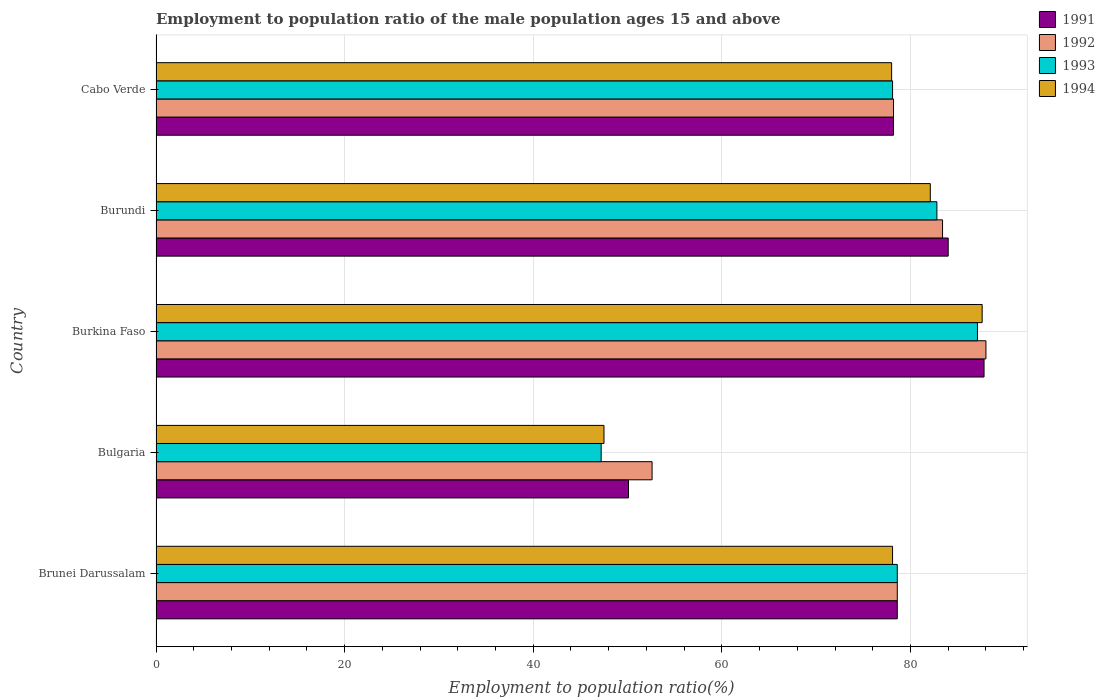What is the label of the 5th group of bars from the top?
Give a very brief answer. Brunei Darussalam. In how many cases, is the number of bars for a given country not equal to the number of legend labels?
Your answer should be compact. 0. What is the employment to population ratio in 1992 in Brunei Darussalam?
Provide a succinct answer. 78.6. Across all countries, what is the maximum employment to population ratio in 1993?
Ensure brevity in your answer.  87.1. Across all countries, what is the minimum employment to population ratio in 1994?
Your response must be concise. 47.5. In which country was the employment to population ratio in 1991 maximum?
Your answer should be very brief. Burkina Faso. What is the total employment to population ratio in 1994 in the graph?
Your answer should be compact. 373.3. What is the difference between the employment to population ratio in 1993 in Burundi and that in Cabo Verde?
Offer a very short reply. 4.7. What is the difference between the employment to population ratio in 1994 in Cabo Verde and the employment to population ratio in 1992 in Burkina Faso?
Provide a succinct answer. -10. What is the average employment to population ratio in 1993 per country?
Keep it short and to the point. 74.76. What is the difference between the employment to population ratio in 1991 and employment to population ratio in 1993 in Burkina Faso?
Keep it short and to the point. 0.7. What is the ratio of the employment to population ratio in 1991 in Bulgaria to that in Cabo Verde?
Your answer should be compact. 0.64. Is the employment to population ratio in 1991 in Burkina Faso less than that in Cabo Verde?
Provide a succinct answer. No. What is the difference between the highest and the second highest employment to population ratio in 1992?
Make the answer very short. 4.6. What is the difference between the highest and the lowest employment to population ratio in 1994?
Your answer should be very brief. 40.1. What does the 1st bar from the top in Brunei Darussalam represents?
Keep it short and to the point. 1994. Is it the case that in every country, the sum of the employment to population ratio in 1992 and employment to population ratio in 1994 is greater than the employment to population ratio in 1993?
Offer a very short reply. Yes. How many bars are there?
Your answer should be very brief. 20. Are all the bars in the graph horizontal?
Your answer should be compact. Yes. Are the values on the major ticks of X-axis written in scientific E-notation?
Give a very brief answer. No. Does the graph contain any zero values?
Your response must be concise. No. Does the graph contain grids?
Provide a succinct answer. Yes. Where does the legend appear in the graph?
Give a very brief answer. Top right. How many legend labels are there?
Offer a very short reply. 4. How are the legend labels stacked?
Provide a short and direct response. Vertical. What is the title of the graph?
Your answer should be compact. Employment to population ratio of the male population ages 15 and above. What is the label or title of the X-axis?
Your answer should be compact. Employment to population ratio(%). What is the label or title of the Y-axis?
Your answer should be compact. Country. What is the Employment to population ratio(%) in 1991 in Brunei Darussalam?
Ensure brevity in your answer.  78.6. What is the Employment to population ratio(%) of 1992 in Brunei Darussalam?
Offer a terse response. 78.6. What is the Employment to population ratio(%) in 1993 in Brunei Darussalam?
Make the answer very short. 78.6. What is the Employment to population ratio(%) in 1994 in Brunei Darussalam?
Offer a very short reply. 78.1. What is the Employment to population ratio(%) in 1991 in Bulgaria?
Offer a terse response. 50.1. What is the Employment to population ratio(%) in 1992 in Bulgaria?
Your answer should be compact. 52.6. What is the Employment to population ratio(%) of 1993 in Bulgaria?
Offer a very short reply. 47.2. What is the Employment to population ratio(%) in 1994 in Bulgaria?
Keep it short and to the point. 47.5. What is the Employment to population ratio(%) of 1991 in Burkina Faso?
Provide a short and direct response. 87.8. What is the Employment to population ratio(%) of 1992 in Burkina Faso?
Make the answer very short. 88. What is the Employment to population ratio(%) of 1993 in Burkina Faso?
Your response must be concise. 87.1. What is the Employment to population ratio(%) of 1994 in Burkina Faso?
Your answer should be compact. 87.6. What is the Employment to population ratio(%) in 1991 in Burundi?
Offer a terse response. 84. What is the Employment to population ratio(%) in 1992 in Burundi?
Provide a short and direct response. 83.4. What is the Employment to population ratio(%) of 1993 in Burundi?
Give a very brief answer. 82.8. What is the Employment to population ratio(%) in 1994 in Burundi?
Provide a short and direct response. 82.1. What is the Employment to population ratio(%) of 1991 in Cabo Verde?
Give a very brief answer. 78.2. What is the Employment to population ratio(%) in 1992 in Cabo Verde?
Offer a terse response. 78.2. What is the Employment to population ratio(%) of 1993 in Cabo Verde?
Your response must be concise. 78.1. Across all countries, what is the maximum Employment to population ratio(%) of 1991?
Offer a very short reply. 87.8. Across all countries, what is the maximum Employment to population ratio(%) of 1993?
Provide a short and direct response. 87.1. Across all countries, what is the maximum Employment to population ratio(%) of 1994?
Offer a very short reply. 87.6. Across all countries, what is the minimum Employment to population ratio(%) in 1991?
Offer a terse response. 50.1. Across all countries, what is the minimum Employment to population ratio(%) in 1992?
Give a very brief answer. 52.6. Across all countries, what is the minimum Employment to population ratio(%) of 1993?
Provide a succinct answer. 47.2. Across all countries, what is the minimum Employment to population ratio(%) in 1994?
Give a very brief answer. 47.5. What is the total Employment to population ratio(%) in 1991 in the graph?
Your answer should be compact. 378.7. What is the total Employment to population ratio(%) of 1992 in the graph?
Ensure brevity in your answer.  380.8. What is the total Employment to population ratio(%) in 1993 in the graph?
Offer a terse response. 373.8. What is the total Employment to population ratio(%) in 1994 in the graph?
Your response must be concise. 373.3. What is the difference between the Employment to population ratio(%) in 1991 in Brunei Darussalam and that in Bulgaria?
Give a very brief answer. 28.5. What is the difference between the Employment to population ratio(%) of 1992 in Brunei Darussalam and that in Bulgaria?
Give a very brief answer. 26. What is the difference between the Employment to population ratio(%) in 1993 in Brunei Darussalam and that in Bulgaria?
Offer a terse response. 31.4. What is the difference between the Employment to population ratio(%) of 1994 in Brunei Darussalam and that in Bulgaria?
Your answer should be very brief. 30.6. What is the difference between the Employment to population ratio(%) in 1991 in Brunei Darussalam and that in Burkina Faso?
Offer a terse response. -9.2. What is the difference between the Employment to population ratio(%) in 1993 in Brunei Darussalam and that in Burkina Faso?
Provide a short and direct response. -8.5. What is the difference between the Employment to population ratio(%) of 1992 in Brunei Darussalam and that in Burundi?
Your answer should be compact. -4.8. What is the difference between the Employment to population ratio(%) in 1993 in Brunei Darussalam and that in Burundi?
Offer a very short reply. -4.2. What is the difference between the Employment to population ratio(%) in 1992 in Brunei Darussalam and that in Cabo Verde?
Offer a very short reply. 0.4. What is the difference between the Employment to population ratio(%) in 1991 in Bulgaria and that in Burkina Faso?
Your answer should be very brief. -37.7. What is the difference between the Employment to population ratio(%) of 1992 in Bulgaria and that in Burkina Faso?
Give a very brief answer. -35.4. What is the difference between the Employment to population ratio(%) of 1993 in Bulgaria and that in Burkina Faso?
Offer a very short reply. -39.9. What is the difference between the Employment to population ratio(%) of 1994 in Bulgaria and that in Burkina Faso?
Keep it short and to the point. -40.1. What is the difference between the Employment to population ratio(%) of 1991 in Bulgaria and that in Burundi?
Offer a terse response. -33.9. What is the difference between the Employment to population ratio(%) in 1992 in Bulgaria and that in Burundi?
Make the answer very short. -30.8. What is the difference between the Employment to population ratio(%) in 1993 in Bulgaria and that in Burundi?
Give a very brief answer. -35.6. What is the difference between the Employment to population ratio(%) of 1994 in Bulgaria and that in Burundi?
Make the answer very short. -34.6. What is the difference between the Employment to population ratio(%) in 1991 in Bulgaria and that in Cabo Verde?
Ensure brevity in your answer.  -28.1. What is the difference between the Employment to population ratio(%) of 1992 in Bulgaria and that in Cabo Verde?
Give a very brief answer. -25.6. What is the difference between the Employment to population ratio(%) in 1993 in Bulgaria and that in Cabo Verde?
Your answer should be very brief. -30.9. What is the difference between the Employment to population ratio(%) in 1994 in Bulgaria and that in Cabo Verde?
Keep it short and to the point. -30.5. What is the difference between the Employment to population ratio(%) of 1992 in Burkina Faso and that in Burundi?
Your response must be concise. 4.6. What is the difference between the Employment to population ratio(%) of 1994 in Burkina Faso and that in Burundi?
Ensure brevity in your answer.  5.5. What is the difference between the Employment to population ratio(%) of 1993 in Burundi and that in Cabo Verde?
Your response must be concise. 4.7. What is the difference between the Employment to population ratio(%) of 1991 in Brunei Darussalam and the Employment to population ratio(%) of 1993 in Bulgaria?
Make the answer very short. 31.4. What is the difference between the Employment to population ratio(%) in 1991 in Brunei Darussalam and the Employment to population ratio(%) in 1994 in Bulgaria?
Keep it short and to the point. 31.1. What is the difference between the Employment to population ratio(%) of 1992 in Brunei Darussalam and the Employment to population ratio(%) of 1993 in Bulgaria?
Your answer should be compact. 31.4. What is the difference between the Employment to population ratio(%) in 1992 in Brunei Darussalam and the Employment to population ratio(%) in 1994 in Bulgaria?
Offer a very short reply. 31.1. What is the difference between the Employment to population ratio(%) of 1993 in Brunei Darussalam and the Employment to population ratio(%) of 1994 in Bulgaria?
Offer a very short reply. 31.1. What is the difference between the Employment to population ratio(%) of 1991 in Brunei Darussalam and the Employment to population ratio(%) of 1994 in Burkina Faso?
Your response must be concise. -9. What is the difference between the Employment to population ratio(%) of 1992 in Brunei Darussalam and the Employment to population ratio(%) of 1993 in Burkina Faso?
Provide a succinct answer. -8.5. What is the difference between the Employment to population ratio(%) in 1991 in Brunei Darussalam and the Employment to population ratio(%) in 1993 in Burundi?
Offer a very short reply. -4.2. What is the difference between the Employment to population ratio(%) in 1991 in Brunei Darussalam and the Employment to population ratio(%) in 1994 in Burundi?
Make the answer very short. -3.5. What is the difference between the Employment to population ratio(%) in 1992 in Brunei Darussalam and the Employment to population ratio(%) in 1994 in Burundi?
Your answer should be very brief. -3.5. What is the difference between the Employment to population ratio(%) of 1993 in Brunei Darussalam and the Employment to population ratio(%) of 1994 in Burundi?
Ensure brevity in your answer.  -3.5. What is the difference between the Employment to population ratio(%) of 1991 in Brunei Darussalam and the Employment to population ratio(%) of 1993 in Cabo Verde?
Give a very brief answer. 0.5. What is the difference between the Employment to population ratio(%) of 1992 in Brunei Darussalam and the Employment to population ratio(%) of 1993 in Cabo Verde?
Give a very brief answer. 0.5. What is the difference between the Employment to population ratio(%) of 1992 in Brunei Darussalam and the Employment to population ratio(%) of 1994 in Cabo Verde?
Give a very brief answer. 0.6. What is the difference between the Employment to population ratio(%) of 1993 in Brunei Darussalam and the Employment to population ratio(%) of 1994 in Cabo Verde?
Your answer should be very brief. 0.6. What is the difference between the Employment to population ratio(%) in 1991 in Bulgaria and the Employment to population ratio(%) in 1992 in Burkina Faso?
Your answer should be very brief. -37.9. What is the difference between the Employment to population ratio(%) in 1991 in Bulgaria and the Employment to population ratio(%) in 1993 in Burkina Faso?
Offer a very short reply. -37. What is the difference between the Employment to population ratio(%) of 1991 in Bulgaria and the Employment to population ratio(%) of 1994 in Burkina Faso?
Your answer should be very brief. -37.5. What is the difference between the Employment to population ratio(%) in 1992 in Bulgaria and the Employment to population ratio(%) in 1993 in Burkina Faso?
Ensure brevity in your answer.  -34.5. What is the difference between the Employment to population ratio(%) in 1992 in Bulgaria and the Employment to population ratio(%) in 1994 in Burkina Faso?
Your answer should be compact. -35. What is the difference between the Employment to population ratio(%) of 1993 in Bulgaria and the Employment to population ratio(%) of 1994 in Burkina Faso?
Offer a terse response. -40.4. What is the difference between the Employment to population ratio(%) in 1991 in Bulgaria and the Employment to population ratio(%) in 1992 in Burundi?
Give a very brief answer. -33.3. What is the difference between the Employment to population ratio(%) of 1991 in Bulgaria and the Employment to population ratio(%) of 1993 in Burundi?
Give a very brief answer. -32.7. What is the difference between the Employment to population ratio(%) of 1991 in Bulgaria and the Employment to population ratio(%) of 1994 in Burundi?
Your answer should be very brief. -32. What is the difference between the Employment to population ratio(%) in 1992 in Bulgaria and the Employment to population ratio(%) in 1993 in Burundi?
Give a very brief answer. -30.2. What is the difference between the Employment to population ratio(%) of 1992 in Bulgaria and the Employment to population ratio(%) of 1994 in Burundi?
Keep it short and to the point. -29.5. What is the difference between the Employment to population ratio(%) in 1993 in Bulgaria and the Employment to population ratio(%) in 1994 in Burundi?
Offer a terse response. -34.9. What is the difference between the Employment to population ratio(%) of 1991 in Bulgaria and the Employment to population ratio(%) of 1992 in Cabo Verde?
Provide a short and direct response. -28.1. What is the difference between the Employment to population ratio(%) of 1991 in Bulgaria and the Employment to population ratio(%) of 1993 in Cabo Verde?
Offer a very short reply. -28. What is the difference between the Employment to population ratio(%) in 1991 in Bulgaria and the Employment to population ratio(%) in 1994 in Cabo Verde?
Offer a terse response. -27.9. What is the difference between the Employment to population ratio(%) in 1992 in Bulgaria and the Employment to population ratio(%) in 1993 in Cabo Verde?
Give a very brief answer. -25.5. What is the difference between the Employment to population ratio(%) of 1992 in Bulgaria and the Employment to population ratio(%) of 1994 in Cabo Verde?
Give a very brief answer. -25.4. What is the difference between the Employment to population ratio(%) of 1993 in Bulgaria and the Employment to population ratio(%) of 1994 in Cabo Verde?
Offer a very short reply. -30.8. What is the difference between the Employment to population ratio(%) of 1993 in Burkina Faso and the Employment to population ratio(%) of 1994 in Burundi?
Make the answer very short. 5. What is the difference between the Employment to population ratio(%) in 1991 in Burkina Faso and the Employment to population ratio(%) in 1992 in Cabo Verde?
Provide a short and direct response. 9.6. What is the difference between the Employment to population ratio(%) in 1991 in Burkina Faso and the Employment to population ratio(%) in 1993 in Cabo Verde?
Your answer should be compact. 9.7. What is the difference between the Employment to population ratio(%) of 1991 in Burkina Faso and the Employment to population ratio(%) of 1994 in Cabo Verde?
Your answer should be compact. 9.8. What is the difference between the Employment to population ratio(%) in 1992 in Burkina Faso and the Employment to population ratio(%) in 1994 in Cabo Verde?
Your answer should be compact. 10. What is the difference between the Employment to population ratio(%) in 1991 in Burundi and the Employment to population ratio(%) in 1993 in Cabo Verde?
Ensure brevity in your answer.  5.9. What is the difference between the Employment to population ratio(%) of 1992 in Burundi and the Employment to population ratio(%) of 1994 in Cabo Verde?
Give a very brief answer. 5.4. What is the average Employment to population ratio(%) of 1991 per country?
Provide a short and direct response. 75.74. What is the average Employment to population ratio(%) in 1992 per country?
Provide a succinct answer. 76.16. What is the average Employment to population ratio(%) of 1993 per country?
Offer a terse response. 74.76. What is the average Employment to population ratio(%) in 1994 per country?
Ensure brevity in your answer.  74.66. What is the difference between the Employment to population ratio(%) in 1991 and Employment to population ratio(%) in 1992 in Brunei Darussalam?
Your answer should be very brief. 0. What is the difference between the Employment to population ratio(%) of 1991 and Employment to population ratio(%) of 1993 in Brunei Darussalam?
Ensure brevity in your answer.  0. What is the difference between the Employment to population ratio(%) in 1992 and Employment to population ratio(%) in 1993 in Brunei Darussalam?
Make the answer very short. 0. What is the difference between the Employment to population ratio(%) of 1992 and Employment to population ratio(%) of 1994 in Brunei Darussalam?
Provide a short and direct response. 0.5. What is the difference between the Employment to population ratio(%) of 1993 and Employment to population ratio(%) of 1994 in Brunei Darussalam?
Ensure brevity in your answer.  0.5. What is the difference between the Employment to population ratio(%) of 1991 and Employment to population ratio(%) of 1992 in Bulgaria?
Provide a succinct answer. -2.5. What is the difference between the Employment to population ratio(%) in 1991 and Employment to population ratio(%) in 1993 in Bulgaria?
Offer a terse response. 2.9. What is the difference between the Employment to population ratio(%) in 1992 and Employment to population ratio(%) in 1993 in Bulgaria?
Your answer should be very brief. 5.4. What is the difference between the Employment to population ratio(%) in 1992 and Employment to population ratio(%) in 1994 in Bulgaria?
Your answer should be compact. 5.1. What is the difference between the Employment to population ratio(%) of 1993 and Employment to population ratio(%) of 1994 in Bulgaria?
Keep it short and to the point. -0.3. What is the difference between the Employment to population ratio(%) of 1991 and Employment to population ratio(%) of 1993 in Burkina Faso?
Ensure brevity in your answer.  0.7. What is the difference between the Employment to population ratio(%) in 1991 and Employment to population ratio(%) in 1992 in Burundi?
Your response must be concise. 0.6. What is the difference between the Employment to population ratio(%) in 1992 and Employment to population ratio(%) in 1994 in Burundi?
Offer a very short reply. 1.3. What is the difference between the Employment to population ratio(%) in 1992 and Employment to population ratio(%) in 1993 in Cabo Verde?
Offer a very short reply. 0.1. What is the difference between the Employment to population ratio(%) in 1992 and Employment to population ratio(%) in 1994 in Cabo Verde?
Your answer should be compact. 0.2. What is the ratio of the Employment to population ratio(%) in 1991 in Brunei Darussalam to that in Bulgaria?
Ensure brevity in your answer.  1.57. What is the ratio of the Employment to population ratio(%) in 1992 in Brunei Darussalam to that in Bulgaria?
Your response must be concise. 1.49. What is the ratio of the Employment to population ratio(%) in 1993 in Brunei Darussalam to that in Bulgaria?
Offer a very short reply. 1.67. What is the ratio of the Employment to population ratio(%) in 1994 in Brunei Darussalam to that in Bulgaria?
Provide a short and direct response. 1.64. What is the ratio of the Employment to population ratio(%) of 1991 in Brunei Darussalam to that in Burkina Faso?
Provide a succinct answer. 0.9. What is the ratio of the Employment to population ratio(%) in 1992 in Brunei Darussalam to that in Burkina Faso?
Your answer should be very brief. 0.89. What is the ratio of the Employment to population ratio(%) of 1993 in Brunei Darussalam to that in Burkina Faso?
Keep it short and to the point. 0.9. What is the ratio of the Employment to population ratio(%) in 1994 in Brunei Darussalam to that in Burkina Faso?
Offer a terse response. 0.89. What is the ratio of the Employment to population ratio(%) in 1991 in Brunei Darussalam to that in Burundi?
Your answer should be very brief. 0.94. What is the ratio of the Employment to population ratio(%) of 1992 in Brunei Darussalam to that in Burundi?
Ensure brevity in your answer.  0.94. What is the ratio of the Employment to population ratio(%) of 1993 in Brunei Darussalam to that in Burundi?
Your answer should be compact. 0.95. What is the ratio of the Employment to population ratio(%) of 1994 in Brunei Darussalam to that in Burundi?
Your response must be concise. 0.95. What is the ratio of the Employment to population ratio(%) of 1991 in Brunei Darussalam to that in Cabo Verde?
Keep it short and to the point. 1.01. What is the ratio of the Employment to population ratio(%) in 1993 in Brunei Darussalam to that in Cabo Verde?
Your answer should be compact. 1.01. What is the ratio of the Employment to population ratio(%) of 1994 in Brunei Darussalam to that in Cabo Verde?
Your answer should be very brief. 1. What is the ratio of the Employment to population ratio(%) of 1991 in Bulgaria to that in Burkina Faso?
Provide a short and direct response. 0.57. What is the ratio of the Employment to population ratio(%) in 1992 in Bulgaria to that in Burkina Faso?
Give a very brief answer. 0.6. What is the ratio of the Employment to population ratio(%) of 1993 in Bulgaria to that in Burkina Faso?
Ensure brevity in your answer.  0.54. What is the ratio of the Employment to population ratio(%) of 1994 in Bulgaria to that in Burkina Faso?
Provide a short and direct response. 0.54. What is the ratio of the Employment to population ratio(%) of 1991 in Bulgaria to that in Burundi?
Provide a short and direct response. 0.6. What is the ratio of the Employment to population ratio(%) in 1992 in Bulgaria to that in Burundi?
Provide a short and direct response. 0.63. What is the ratio of the Employment to population ratio(%) of 1993 in Bulgaria to that in Burundi?
Offer a very short reply. 0.57. What is the ratio of the Employment to population ratio(%) in 1994 in Bulgaria to that in Burundi?
Your response must be concise. 0.58. What is the ratio of the Employment to population ratio(%) of 1991 in Bulgaria to that in Cabo Verde?
Your answer should be very brief. 0.64. What is the ratio of the Employment to population ratio(%) in 1992 in Bulgaria to that in Cabo Verde?
Make the answer very short. 0.67. What is the ratio of the Employment to population ratio(%) in 1993 in Bulgaria to that in Cabo Verde?
Provide a succinct answer. 0.6. What is the ratio of the Employment to population ratio(%) in 1994 in Bulgaria to that in Cabo Verde?
Your answer should be very brief. 0.61. What is the ratio of the Employment to population ratio(%) of 1991 in Burkina Faso to that in Burundi?
Offer a very short reply. 1.05. What is the ratio of the Employment to population ratio(%) of 1992 in Burkina Faso to that in Burundi?
Offer a very short reply. 1.06. What is the ratio of the Employment to population ratio(%) of 1993 in Burkina Faso to that in Burundi?
Offer a terse response. 1.05. What is the ratio of the Employment to population ratio(%) of 1994 in Burkina Faso to that in Burundi?
Offer a terse response. 1.07. What is the ratio of the Employment to population ratio(%) in 1991 in Burkina Faso to that in Cabo Verde?
Make the answer very short. 1.12. What is the ratio of the Employment to population ratio(%) of 1992 in Burkina Faso to that in Cabo Verde?
Provide a short and direct response. 1.13. What is the ratio of the Employment to population ratio(%) in 1993 in Burkina Faso to that in Cabo Verde?
Your answer should be very brief. 1.12. What is the ratio of the Employment to population ratio(%) of 1994 in Burkina Faso to that in Cabo Verde?
Your response must be concise. 1.12. What is the ratio of the Employment to population ratio(%) of 1991 in Burundi to that in Cabo Verde?
Offer a very short reply. 1.07. What is the ratio of the Employment to population ratio(%) in 1992 in Burundi to that in Cabo Verde?
Ensure brevity in your answer.  1.07. What is the ratio of the Employment to population ratio(%) of 1993 in Burundi to that in Cabo Verde?
Your answer should be very brief. 1.06. What is the ratio of the Employment to population ratio(%) in 1994 in Burundi to that in Cabo Verde?
Your answer should be very brief. 1.05. What is the difference between the highest and the second highest Employment to population ratio(%) in 1991?
Offer a very short reply. 3.8. What is the difference between the highest and the second highest Employment to population ratio(%) of 1994?
Ensure brevity in your answer.  5.5. What is the difference between the highest and the lowest Employment to population ratio(%) of 1991?
Your answer should be very brief. 37.7. What is the difference between the highest and the lowest Employment to population ratio(%) of 1992?
Offer a terse response. 35.4. What is the difference between the highest and the lowest Employment to population ratio(%) in 1993?
Offer a terse response. 39.9. What is the difference between the highest and the lowest Employment to population ratio(%) in 1994?
Make the answer very short. 40.1. 